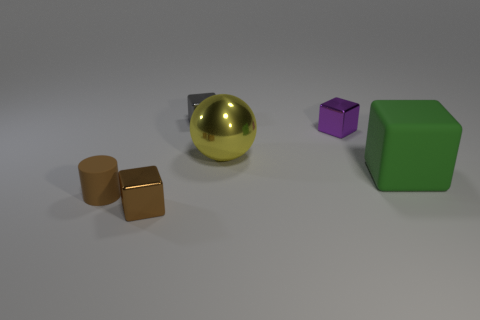Add 2 tiny rubber objects. How many objects exist? 8 Subtract all balls. How many objects are left? 5 Add 1 big purple rubber blocks. How many big purple rubber blocks exist? 1 Subtract 0 red cubes. How many objects are left? 6 Subtract all metallic things. Subtract all tiny brown matte cylinders. How many objects are left? 1 Add 6 yellow things. How many yellow things are left? 7 